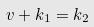Convert formula to latex. <formula><loc_0><loc_0><loc_500><loc_500>v + k _ { 1 } = k _ { 2 }</formula> 